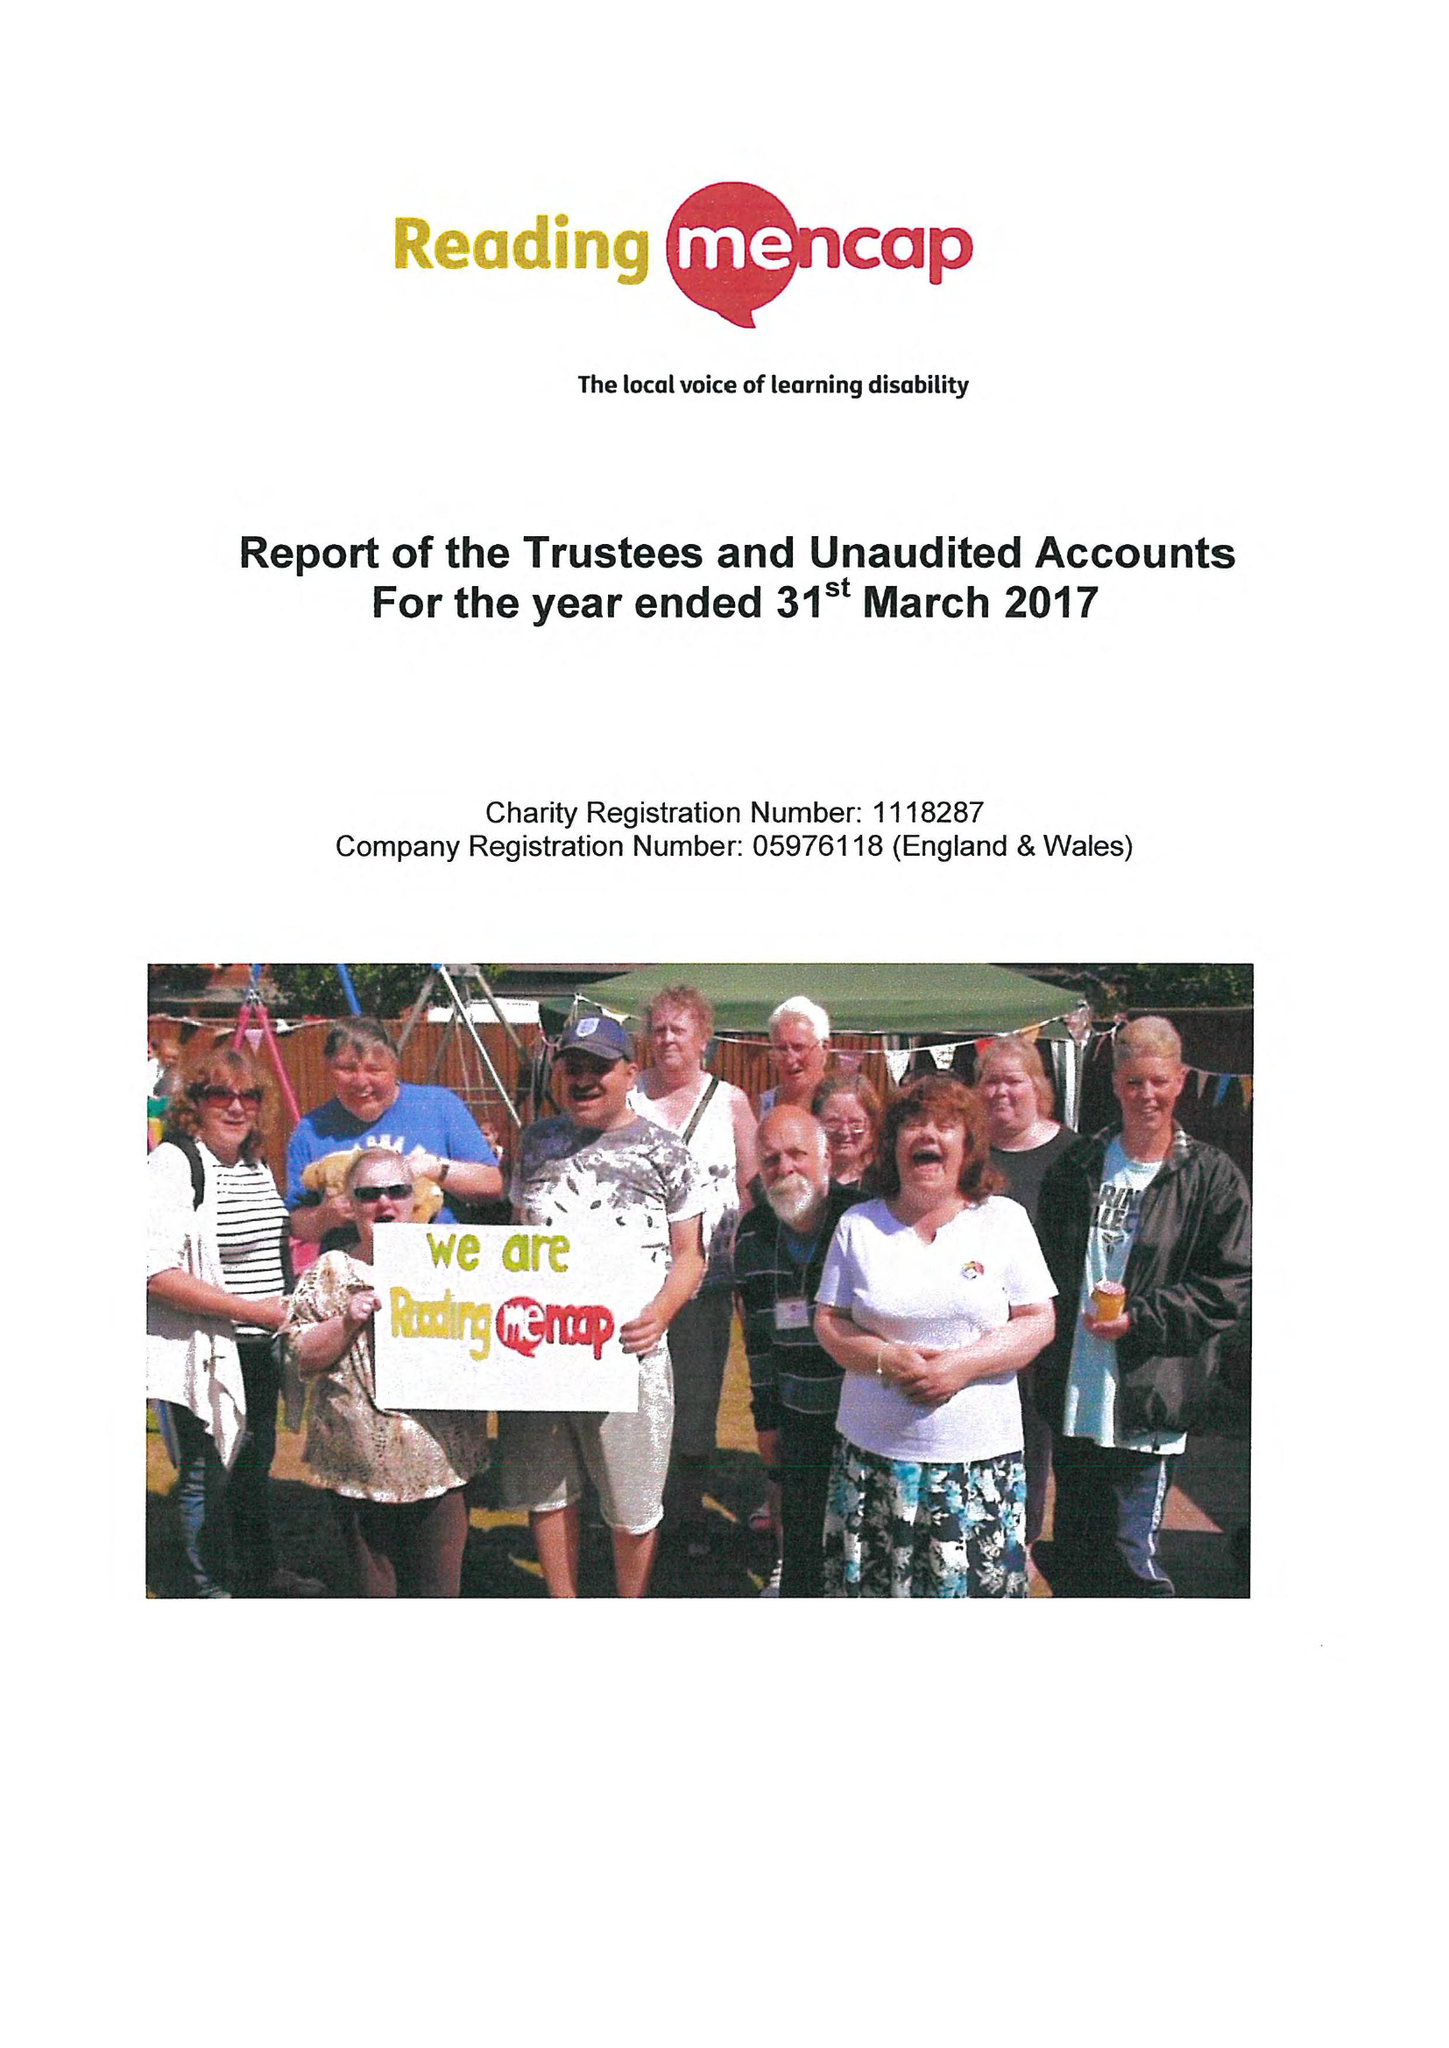What is the value for the charity_number?
Answer the question using a single word or phrase. 1118287 